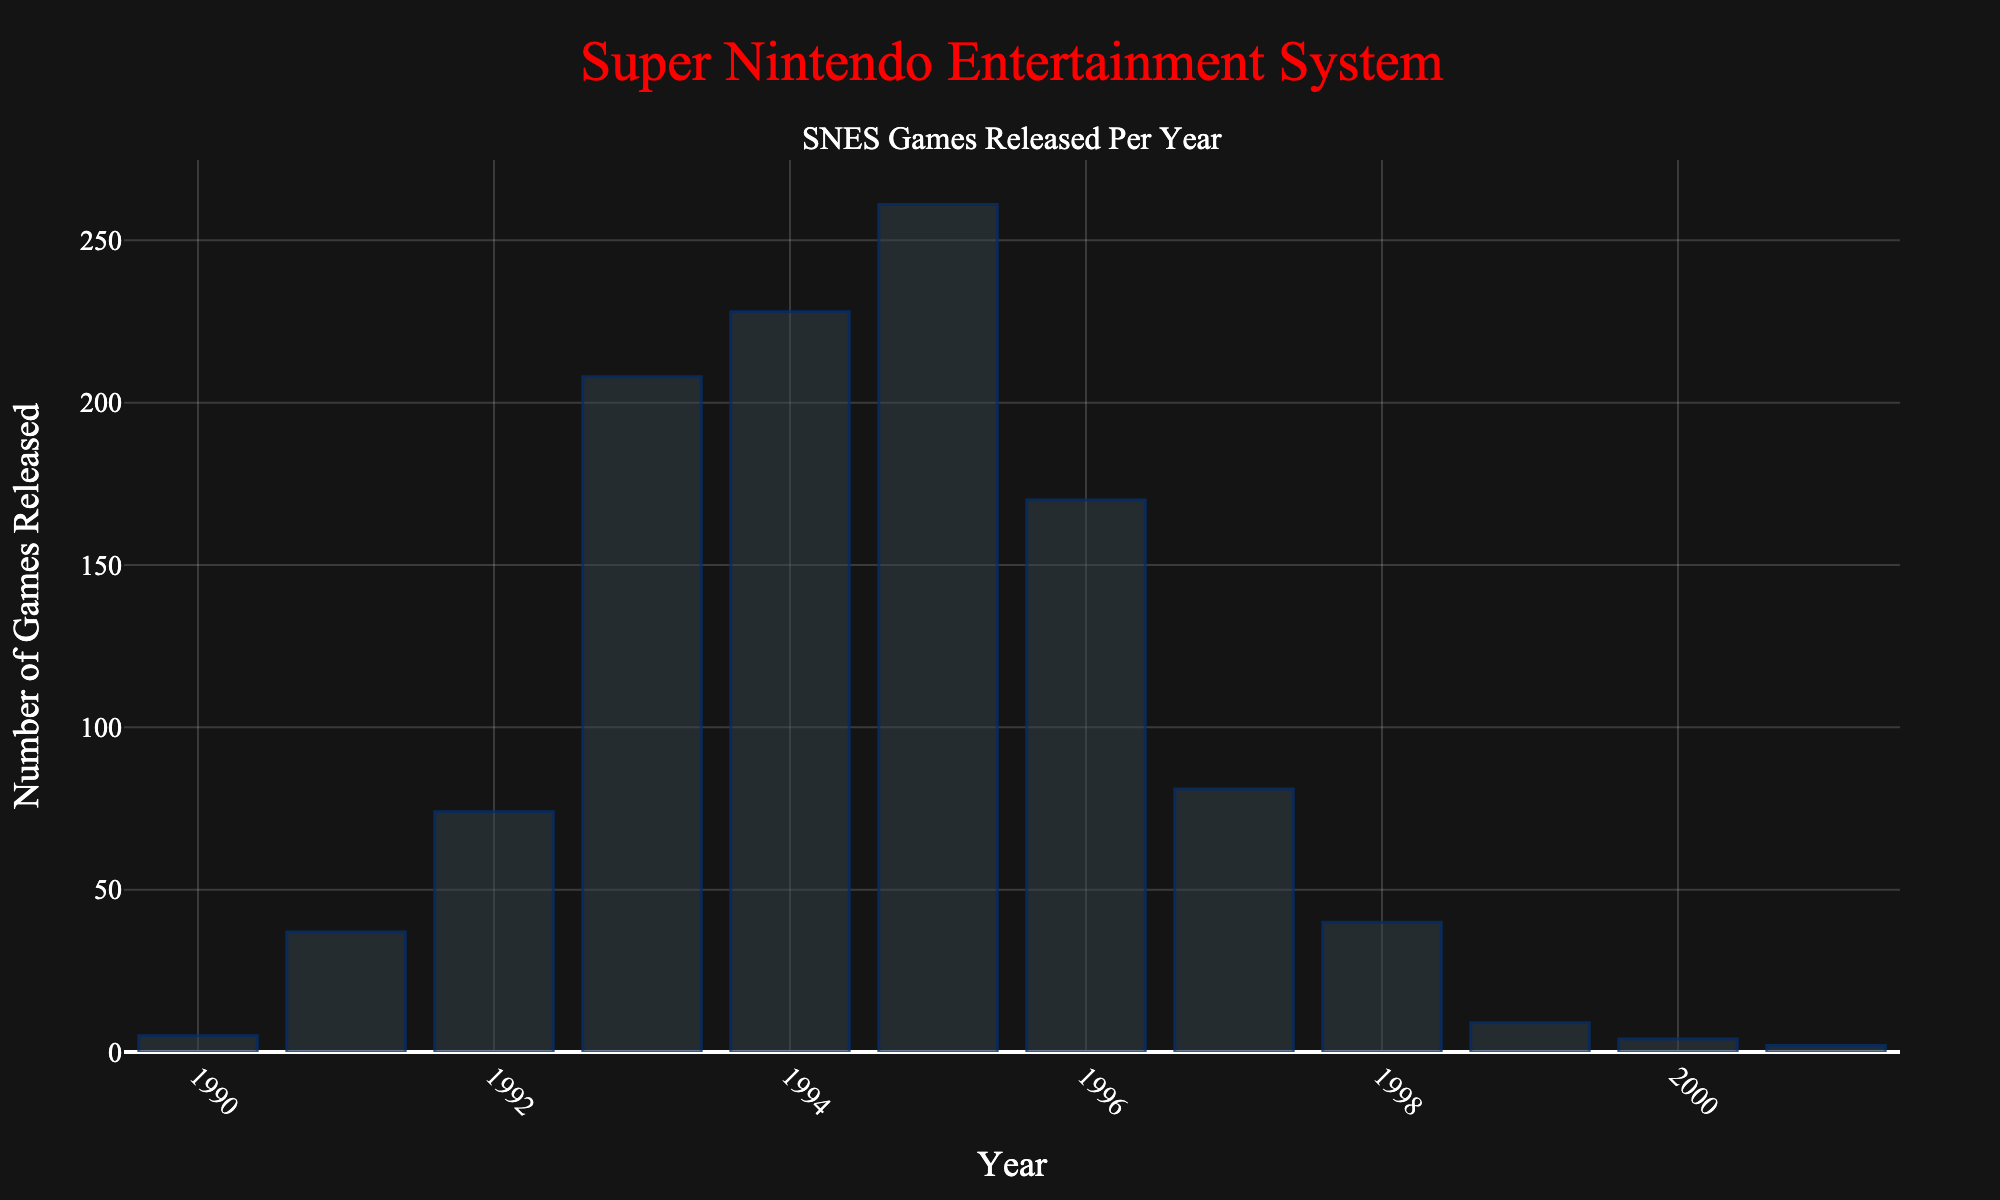How many SNES games were released in 1995? Locate the bar corresponding to the year 1995 in the figure and note the height. The number at the top of the bar is the number of games released in that year.
Answer: 261 In which year were the most SNES games released? Identify the tallest bar in the figure. The x-axis value below this bar indicates the year with the most game releases.
Answer: 1995 What is the difference in the number of SNES games released between 1993 and 1996? Identify the bars for the years 1993 and 1996. Note the number of games released for each year (208 for 1993 and 170 for 1996). Compute the difference: 208 - 170.
Answer: 38 Compare the number of SNES games released in 1991 and 1998. Which year had more releases? Locate the bars for 1991 and 1998. Note the number of games released for each year (37 for 1991 and 40 for 1998). Compare the two numbers: 40 is greater than 37.
Answer: 1998 What is the average number of SNES games released per year from 1990 to 2001? Sum the total number of games released each year from 1990 to 2001. Divide this sum by the number of years (12). (5 + 37 + 74 + 208 + 228 + 261 + 170 + 81 + 40 + 9 + 4 + 2) / 12 = 1119 / 12.
Answer: 93.25 Between which two consecutive years was the largest increase in SNES game releases observed? Examine the differences in the heights of the bars for each pair of consecutive years. The largest increase occurred between 1992 (74) and 1993 (208). Compute the difference: 208 - 74.
Answer: 1992 and 1993 How does the number of SNES games released in 2000 compare to the number in 1990? Compare the height of the bars for the years 1990 and 2000. Note the number of games (5 in 1990 and 4 in 2000). Since 5 is greater than 4, 1990 had more releases.
Answer: 1990 had more releases By what factor did the number of SNES game releases increase from 1990 to 1993? Divide the number of games released in 1993 (208) by the number of games released in 1990 (5). This will give the factor of increase: 208 / 5 = 41.6.
Answer: 41.6 What is the median number of SNES games released per year during the period shown? List all numbers of games released from 1990 to 2001 in ascending order, then find the middle value. (2, 4, 5, 9, 37, 40, 74, 81, 170, 208, 228, 261). The middle values are 74 and 81. The median is the average of these: (74 + 81) / 2.
Answer: 77.5 